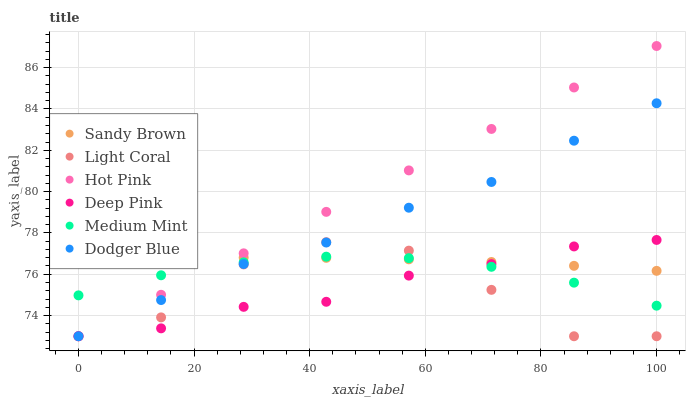Does Light Coral have the minimum area under the curve?
Answer yes or no. Yes. Does Hot Pink have the maximum area under the curve?
Answer yes or no. Yes. Does Deep Pink have the minimum area under the curve?
Answer yes or no. No. Does Deep Pink have the maximum area under the curve?
Answer yes or no. No. Is Hot Pink the smoothest?
Answer yes or no. Yes. Is Light Coral the roughest?
Answer yes or no. Yes. Is Deep Pink the smoothest?
Answer yes or no. No. Is Deep Pink the roughest?
Answer yes or no. No. Does Deep Pink have the lowest value?
Answer yes or no. Yes. Does Sandy Brown have the lowest value?
Answer yes or no. No. Does Hot Pink have the highest value?
Answer yes or no. Yes. Does Deep Pink have the highest value?
Answer yes or no. No. Does Deep Pink intersect Hot Pink?
Answer yes or no. Yes. Is Deep Pink less than Hot Pink?
Answer yes or no. No. Is Deep Pink greater than Hot Pink?
Answer yes or no. No. 